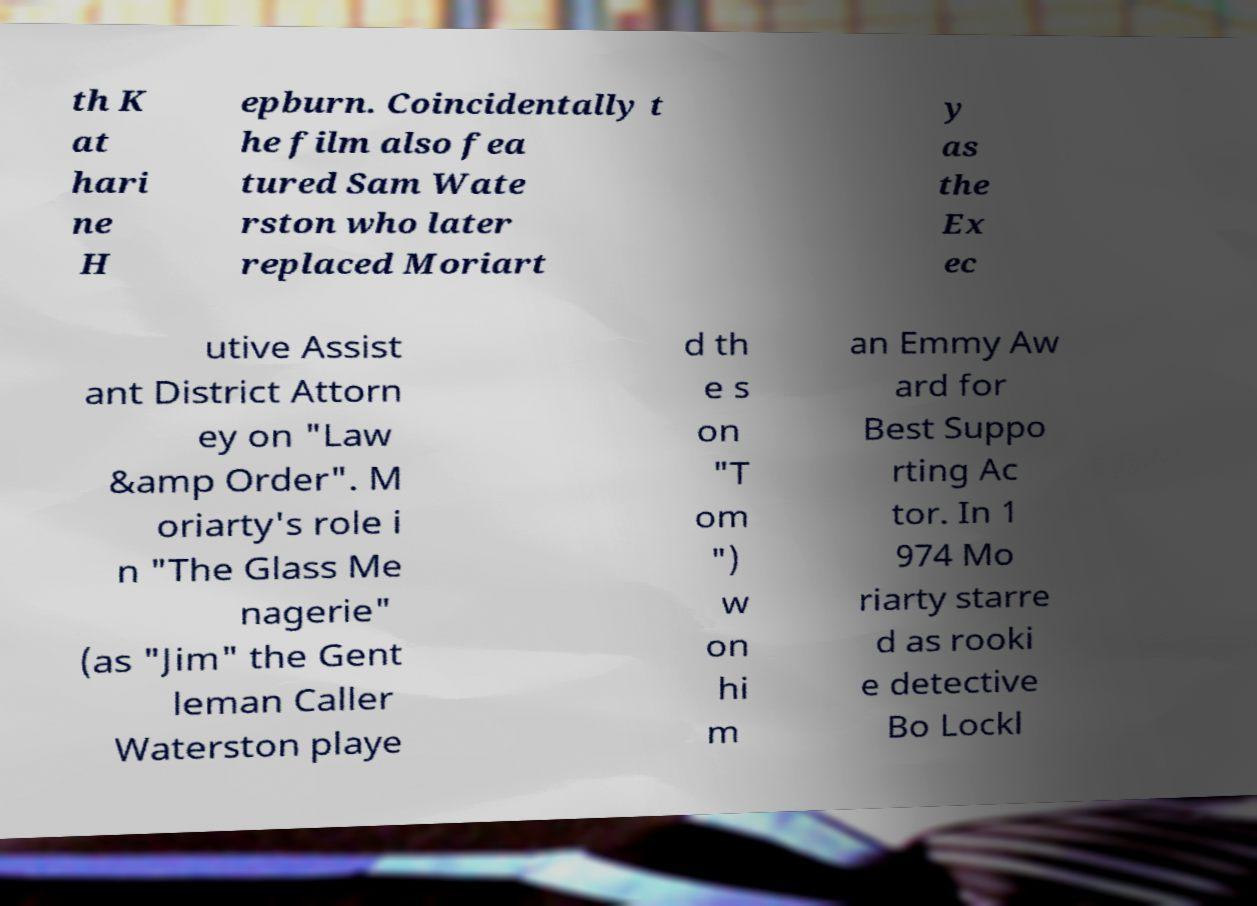Can you accurately transcribe the text from the provided image for me? th K at hari ne H epburn. Coincidentally t he film also fea tured Sam Wate rston who later replaced Moriart y as the Ex ec utive Assist ant District Attorn ey on "Law &amp Order". M oriarty's role i n "The Glass Me nagerie" (as "Jim" the Gent leman Caller Waterston playe d th e s on "T om ") w on hi m an Emmy Aw ard for Best Suppo rting Ac tor. In 1 974 Mo riarty starre d as rooki e detective Bo Lockl 